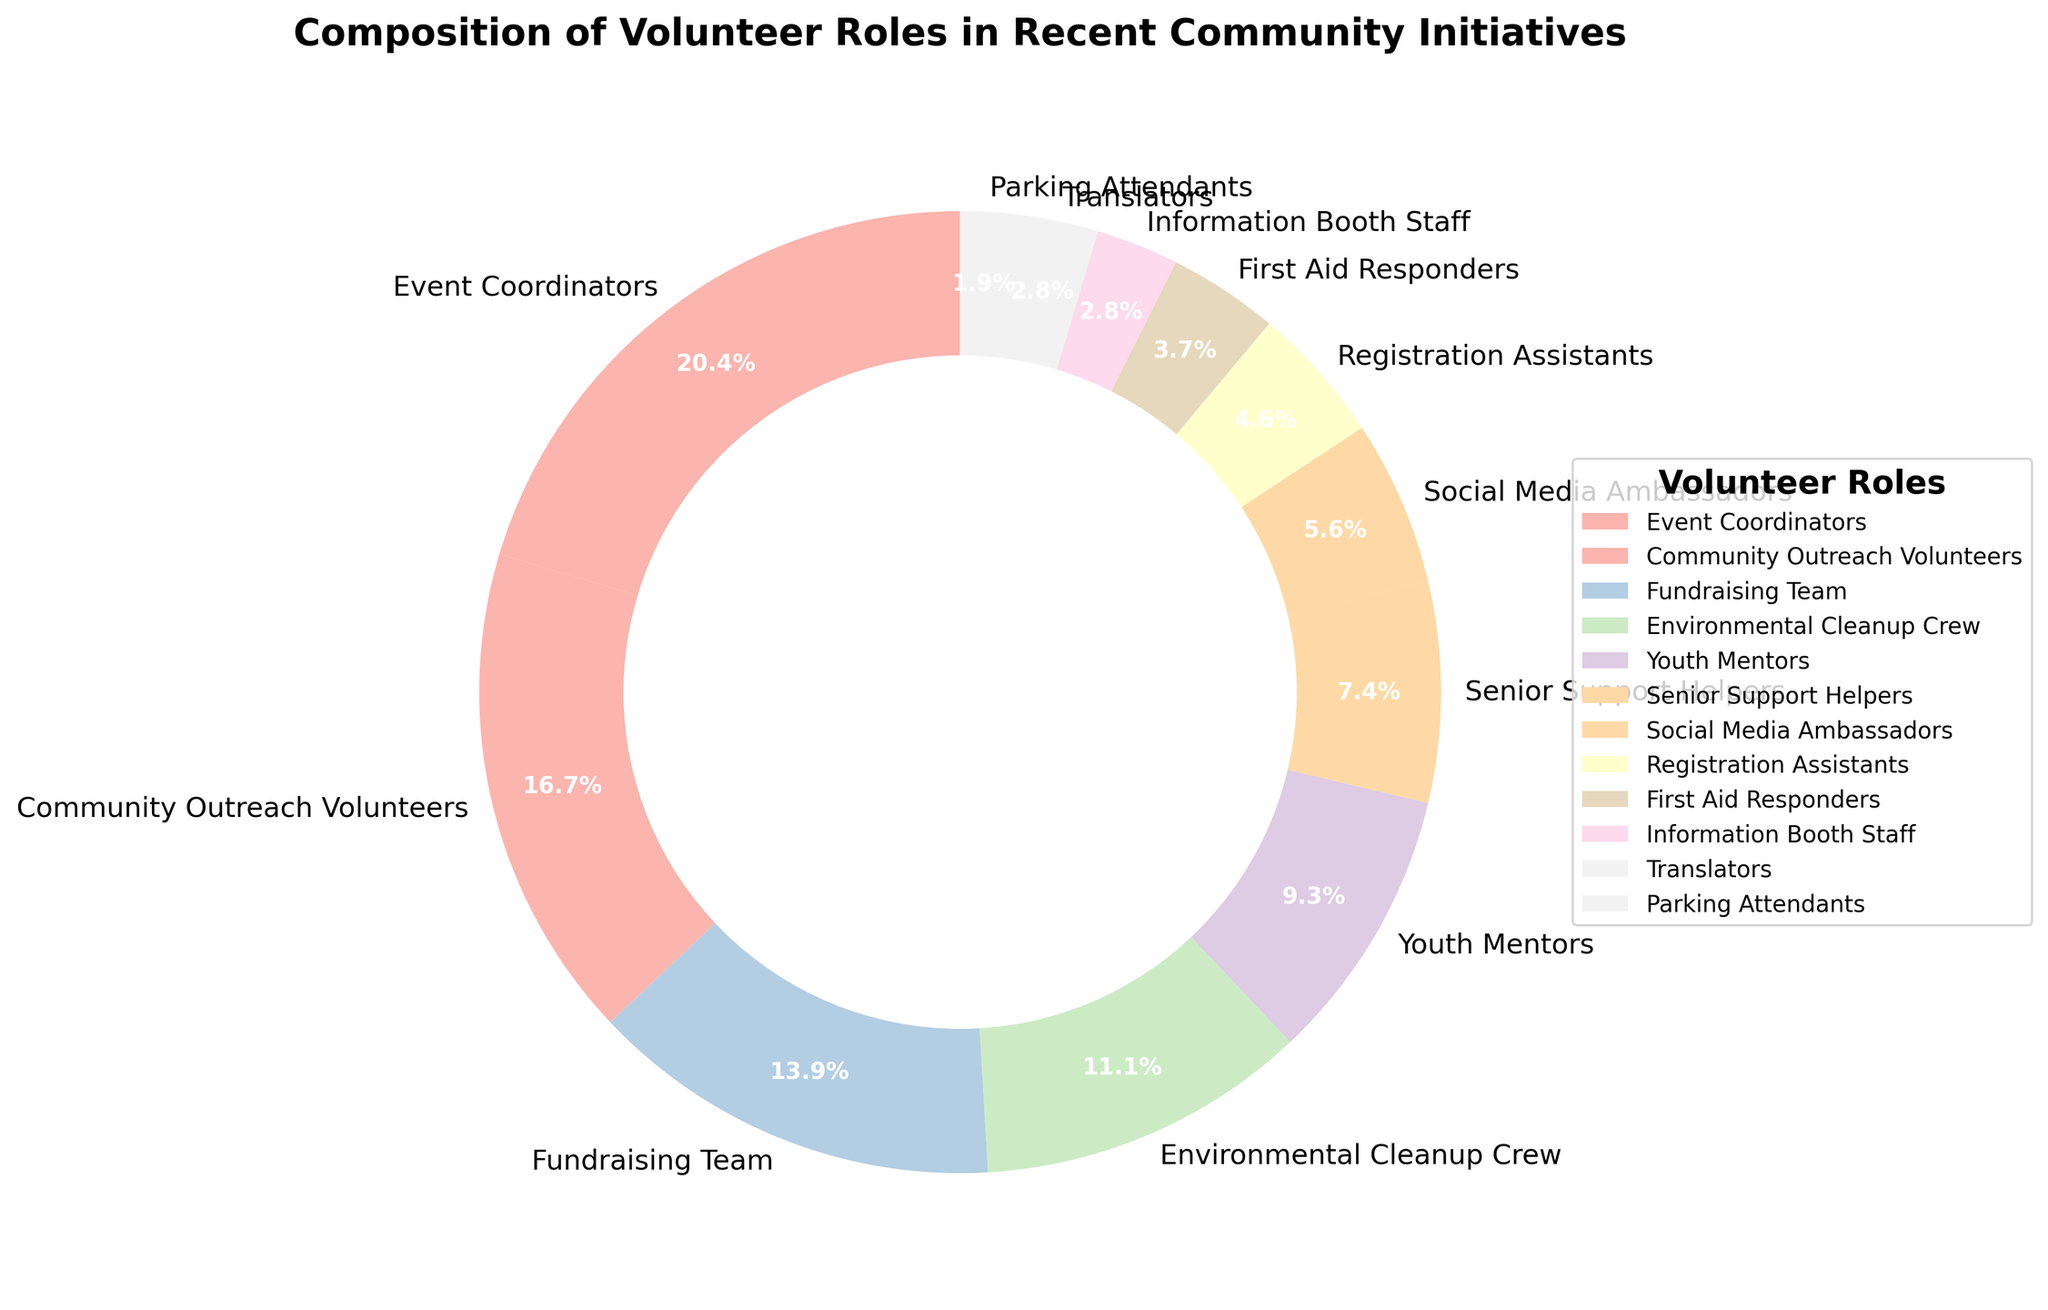Which volunteer role has the largest representation in the community initiatives? The largest representation can be identified by checking the slice with the highest percentage. Event Coordinators have the largest slice at 22%.
Answer: Event Coordinators Which volunteer roles account for less than 5% each? We need to check the roles with slices smaller than 5% in the pie chart. These are Registration Assistants (5%), First Aid Responders (4%), Information Booth Staff (3%), Translators (3%), and Parking Attendants (2%).
Answer: Registration Assistants, First Aid Responders, Information Booth Staff, Translators, Parking Attendants What is the combined percentage of Environmental Cleanup Crew, Youth Mentors, and Social Media Ambassadors? Sum up the percentages of the three roles: Environmental Cleanup Crew (12%), Youth Mentors (10%), and Social Media Ambassadors (6%). 12% + 10% + 6% = 28%.
Answer: 28% Which volunteer role is represented by the smallest slice in the pie chart? The smallest slice corresponds to the role with the lowest percentage. Parking Attendants have the smallest slice at 2%.
Answer: Parking Attendants Compare the sum of percentages of Community Outreach Volunteers and Fundraising Team to the combined percentage of Youth Mentors and Senior Support Helpers. Which is greater? Summing up Community Outreach Volunteers (18%) and Fundraising Team (15%) gives 33%. Summing up Youth Mentors (10%) and Senior Support Helpers (8%) gives 18%. 33% is greater than 18%.
Answer: Community Outreach Volunteers and Fundraising Team If you were to group the volunteer roles into three categories: Coordination (Event Coordinators, Fundraising Team), Support (Youth Mentors, Senior Support Helpers, First Aid Responders), and Assist (Information Booth Staff, Translators, Parking Attendants), which category would have the highest combined percentage? Sum the percentages for each category: Coordination: Event Coordinators (22%) + Fundraising Team (15%) = 37%; Support: Youth Mentors (10%) + Senior Support Helpers (8%) + First Aid Responders (4%) = 22%; Assist: Information Booth Staff (3%) + Translators (3%) + Parking Attendants (2%) = 8%. Coordination has the highest combined percentage.
Answer: Coordination 